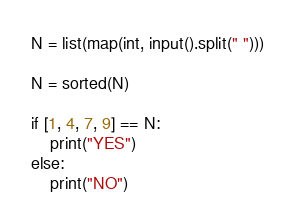Convert code to text. <code><loc_0><loc_0><loc_500><loc_500><_Python_>N = list(map(int, input().split(" ")))

N = sorted(N)

if [1, 4, 7, 9] == N:
    print("YES")
else:
    print("NO")</code> 